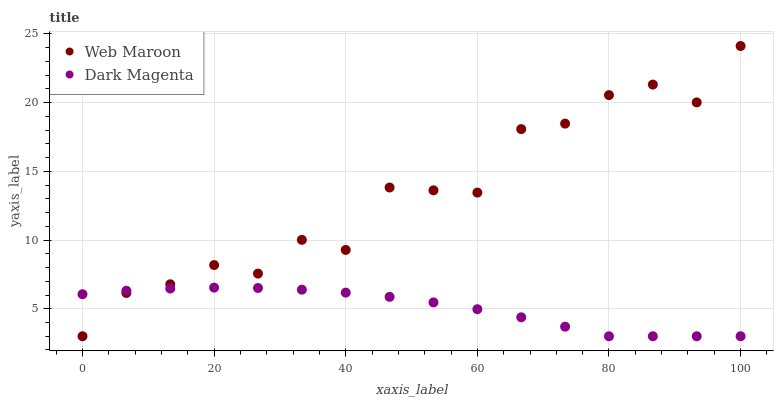Does Dark Magenta have the minimum area under the curve?
Answer yes or no. Yes. Does Web Maroon have the maximum area under the curve?
Answer yes or no. Yes. Does Dark Magenta have the maximum area under the curve?
Answer yes or no. No. Is Dark Magenta the smoothest?
Answer yes or no. Yes. Is Web Maroon the roughest?
Answer yes or no. Yes. Is Dark Magenta the roughest?
Answer yes or no. No. Does Web Maroon have the lowest value?
Answer yes or no. Yes. Does Web Maroon have the highest value?
Answer yes or no. Yes. Does Dark Magenta have the highest value?
Answer yes or no. No. Does Web Maroon intersect Dark Magenta?
Answer yes or no. Yes. Is Web Maroon less than Dark Magenta?
Answer yes or no. No. Is Web Maroon greater than Dark Magenta?
Answer yes or no. No. 